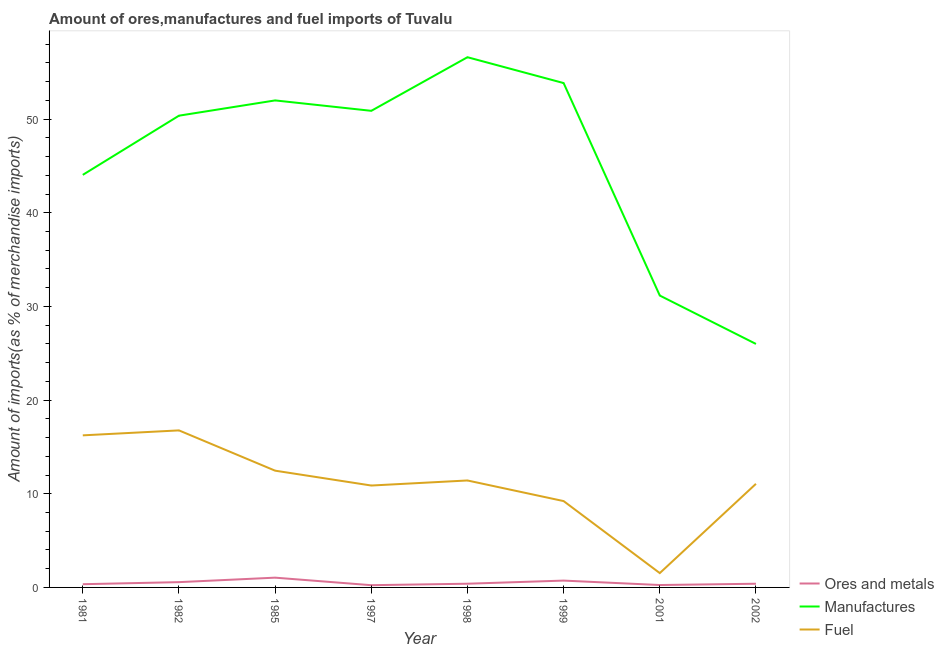How many different coloured lines are there?
Provide a short and direct response. 3. Does the line corresponding to percentage of manufactures imports intersect with the line corresponding to percentage of fuel imports?
Provide a succinct answer. No. Is the number of lines equal to the number of legend labels?
Keep it short and to the point. Yes. What is the percentage of ores and metals imports in 1999?
Your response must be concise. 0.73. Across all years, what is the maximum percentage of fuel imports?
Offer a very short reply. 16.77. Across all years, what is the minimum percentage of fuel imports?
Keep it short and to the point. 1.53. In which year was the percentage of fuel imports maximum?
Ensure brevity in your answer.  1982. In which year was the percentage of fuel imports minimum?
Keep it short and to the point. 2001. What is the total percentage of manufactures imports in the graph?
Keep it short and to the point. 364.89. What is the difference between the percentage of ores and metals imports in 1997 and that in 1998?
Ensure brevity in your answer.  -0.16. What is the difference between the percentage of manufactures imports in 1997 and the percentage of fuel imports in 1982?
Make the answer very short. 34.12. What is the average percentage of fuel imports per year?
Keep it short and to the point. 11.2. In the year 1999, what is the difference between the percentage of manufactures imports and percentage of ores and metals imports?
Ensure brevity in your answer.  53.12. In how many years, is the percentage of fuel imports greater than 2 %?
Ensure brevity in your answer.  7. What is the ratio of the percentage of manufactures imports in 1998 to that in 2002?
Make the answer very short. 2.18. Is the percentage of ores and metals imports in 1981 less than that in 2002?
Give a very brief answer. Yes. Is the difference between the percentage of fuel imports in 1981 and 1982 greater than the difference between the percentage of manufactures imports in 1981 and 1982?
Your answer should be very brief. Yes. What is the difference between the highest and the second highest percentage of ores and metals imports?
Offer a terse response. 0.31. What is the difference between the highest and the lowest percentage of manufactures imports?
Offer a terse response. 30.61. In how many years, is the percentage of fuel imports greater than the average percentage of fuel imports taken over all years?
Make the answer very short. 4. Is it the case that in every year, the sum of the percentage of ores and metals imports and percentage of manufactures imports is greater than the percentage of fuel imports?
Keep it short and to the point. Yes. How many lines are there?
Provide a short and direct response. 3. How many years are there in the graph?
Offer a very short reply. 8. What is the difference between two consecutive major ticks on the Y-axis?
Your answer should be very brief. 10. Are the values on the major ticks of Y-axis written in scientific E-notation?
Your answer should be very brief. No. Does the graph contain grids?
Make the answer very short. No. How many legend labels are there?
Your response must be concise. 3. What is the title of the graph?
Offer a terse response. Amount of ores,manufactures and fuel imports of Tuvalu. What is the label or title of the Y-axis?
Your answer should be compact. Amount of imports(as % of merchandise imports). What is the Amount of imports(as % of merchandise imports) of Ores and metals in 1981?
Offer a terse response. 0.34. What is the Amount of imports(as % of merchandise imports) of Manufactures in 1981?
Your answer should be very brief. 44.04. What is the Amount of imports(as % of merchandise imports) of Fuel in 1981?
Your response must be concise. 16.24. What is the Amount of imports(as % of merchandise imports) in Ores and metals in 1982?
Provide a short and direct response. 0.56. What is the Amount of imports(as % of merchandise imports) of Manufactures in 1982?
Keep it short and to the point. 50.36. What is the Amount of imports(as % of merchandise imports) in Fuel in 1982?
Ensure brevity in your answer.  16.77. What is the Amount of imports(as % of merchandise imports) of Ores and metals in 1985?
Make the answer very short. 1.04. What is the Amount of imports(as % of merchandise imports) of Manufactures in 1985?
Provide a succinct answer. 51.99. What is the Amount of imports(as % of merchandise imports) in Fuel in 1985?
Ensure brevity in your answer.  12.46. What is the Amount of imports(as % of merchandise imports) of Ores and metals in 1997?
Make the answer very short. 0.24. What is the Amount of imports(as % of merchandise imports) in Manufactures in 1997?
Provide a short and direct response. 50.88. What is the Amount of imports(as % of merchandise imports) in Fuel in 1997?
Give a very brief answer. 10.88. What is the Amount of imports(as % of merchandise imports) in Ores and metals in 1998?
Your answer should be very brief. 0.4. What is the Amount of imports(as % of merchandise imports) of Manufactures in 1998?
Offer a terse response. 56.6. What is the Amount of imports(as % of merchandise imports) in Fuel in 1998?
Provide a succinct answer. 11.42. What is the Amount of imports(as % of merchandise imports) of Ores and metals in 1999?
Keep it short and to the point. 0.73. What is the Amount of imports(as % of merchandise imports) of Manufactures in 1999?
Your answer should be very brief. 53.85. What is the Amount of imports(as % of merchandise imports) of Fuel in 1999?
Provide a succinct answer. 9.22. What is the Amount of imports(as % of merchandise imports) in Ores and metals in 2001?
Offer a terse response. 0.26. What is the Amount of imports(as % of merchandise imports) of Manufactures in 2001?
Provide a succinct answer. 31.16. What is the Amount of imports(as % of merchandise imports) of Fuel in 2001?
Offer a terse response. 1.53. What is the Amount of imports(as % of merchandise imports) of Ores and metals in 2002?
Make the answer very short. 0.39. What is the Amount of imports(as % of merchandise imports) of Manufactures in 2002?
Ensure brevity in your answer.  25.99. What is the Amount of imports(as % of merchandise imports) in Fuel in 2002?
Your answer should be compact. 11.06. Across all years, what is the maximum Amount of imports(as % of merchandise imports) in Ores and metals?
Make the answer very short. 1.04. Across all years, what is the maximum Amount of imports(as % of merchandise imports) in Manufactures?
Provide a short and direct response. 56.6. Across all years, what is the maximum Amount of imports(as % of merchandise imports) of Fuel?
Your response must be concise. 16.77. Across all years, what is the minimum Amount of imports(as % of merchandise imports) of Ores and metals?
Provide a short and direct response. 0.24. Across all years, what is the minimum Amount of imports(as % of merchandise imports) of Manufactures?
Ensure brevity in your answer.  25.99. Across all years, what is the minimum Amount of imports(as % of merchandise imports) of Fuel?
Offer a very short reply. 1.53. What is the total Amount of imports(as % of merchandise imports) in Ores and metals in the graph?
Give a very brief answer. 3.97. What is the total Amount of imports(as % of merchandise imports) in Manufactures in the graph?
Make the answer very short. 364.89. What is the total Amount of imports(as % of merchandise imports) in Fuel in the graph?
Offer a very short reply. 89.57. What is the difference between the Amount of imports(as % of merchandise imports) of Ores and metals in 1981 and that in 1982?
Give a very brief answer. -0.22. What is the difference between the Amount of imports(as % of merchandise imports) in Manufactures in 1981 and that in 1982?
Offer a very short reply. -6.32. What is the difference between the Amount of imports(as % of merchandise imports) of Fuel in 1981 and that in 1982?
Provide a short and direct response. -0.53. What is the difference between the Amount of imports(as % of merchandise imports) of Ores and metals in 1981 and that in 1985?
Your answer should be very brief. -0.7. What is the difference between the Amount of imports(as % of merchandise imports) of Manufactures in 1981 and that in 1985?
Make the answer very short. -7.95. What is the difference between the Amount of imports(as % of merchandise imports) of Fuel in 1981 and that in 1985?
Provide a succinct answer. 3.77. What is the difference between the Amount of imports(as % of merchandise imports) in Ores and metals in 1981 and that in 1997?
Make the answer very short. 0.11. What is the difference between the Amount of imports(as % of merchandise imports) in Manufactures in 1981 and that in 1997?
Ensure brevity in your answer.  -6.84. What is the difference between the Amount of imports(as % of merchandise imports) of Fuel in 1981 and that in 1997?
Offer a very short reply. 5.36. What is the difference between the Amount of imports(as % of merchandise imports) in Ores and metals in 1981 and that in 1998?
Keep it short and to the point. -0.05. What is the difference between the Amount of imports(as % of merchandise imports) of Manufactures in 1981 and that in 1998?
Offer a very short reply. -12.56. What is the difference between the Amount of imports(as % of merchandise imports) in Fuel in 1981 and that in 1998?
Your response must be concise. 4.82. What is the difference between the Amount of imports(as % of merchandise imports) in Ores and metals in 1981 and that in 1999?
Provide a succinct answer. -0.39. What is the difference between the Amount of imports(as % of merchandise imports) in Manufactures in 1981 and that in 1999?
Provide a succinct answer. -9.8. What is the difference between the Amount of imports(as % of merchandise imports) of Fuel in 1981 and that in 1999?
Your answer should be compact. 7.02. What is the difference between the Amount of imports(as % of merchandise imports) of Ores and metals in 1981 and that in 2001?
Your response must be concise. 0.09. What is the difference between the Amount of imports(as % of merchandise imports) in Manufactures in 1981 and that in 2001?
Provide a succinct answer. 12.88. What is the difference between the Amount of imports(as % of merchandise imports) in Fuel in 1981 and that in 2001?
Provide a short and direct response. 14.71. What is the difference between the Amount of imports(as % of merchandise imports) in Ores and metals in 1981 and that in 2002?
Your response must be concise. -0.05. What is the difference between the Amount of imports(as % of merchandise imports) of Manufactures in 1981 and that in 2002?
Offer a very short reply. 18.05. What is the difference between the Amount of imports(as % of merchandise imports) in Fuel in 1981 and that in 2002?
Ensure brevity in your answer.  5.17. What is the difference between the Amount of imports(as % of merchandise imports) of Ores and metals in 1982 and that in 1985?
Offer a terse response. -0.48. What is the difference between the Amount of imports(as % of merchandise imports) of Manufactures in 1982 and that in 1985?
Provide a short and direct response. -1.63. What is the difference between the Amount of imports(as % of merchandise imports) of Fuel in 1982 and that in 1985?
Keep it short and to the point. 4.3. What is the difference between the Amount of imports(as % of merchandise imports) in Ores and metals in 1982 and that in 1997?
Keep it short and to the point. 0.33. What is the difference between the Amount of imports(as % of merchandise imports) of Manufactures in 1982 and that in 1997?
Your response must be concise. -0.52. What is the difference between the Amount of imports(as % of merchandise imports) in Fuel in 1982 and that in 1997?
Keep it short and to the point. 5.89. What is the difference between the Amount of imports(as % of merchandise imports) in Ores and metals in 1982 and that in 1998?
Your response must be concise. 0.17. What is the difference between the Amount of imports(as % of merchandise imports) in Manufactures in 1982 and that in 1998?
Make the answer very short. -6.24. What is the difference between the Amount of imports(as % of merchandise imports) of Fuel in 1982 and that in 1998?
Ensure brevity in your answer.  5.35. What is the difference between the Amount of imports(as % of merchandise imports) of Ores and metals in 1982 and that in 1999?
Provide a short and direct response. -0.17. What is the difference between the Amount of imports(as % of merchandise imports) in Manufactures in 1982 and that in 1999?
Offer a terse response. -3.48. What is the difference between the Amount of imports(as % of merchandise imports) in Fuel in 1982 and that in 1999?
Give a very brief answer. 7.55. What is the difference between the Amount of imports(as % of merchandise imports) in Ores and metals in 1982 and that in 2001?
Offer a very short reply. 0.31. What is the difference between the Amount of imports(as % of merchandise imports) in Manufactures in 1982 and that in 2001?
Provide a succinct answer. 19.2. What is the difference between the Amount of imports(as % of merchandise imports) in Fuel in 1982 and that in 2001?
Give a very brief answer. 15.24. What is the difference between the Amount of imports(as % of merchandise imports) of Ores and metals in 1982 and that in 2002?
Your answer should be compact. 0.17. What is the difference between the Amount of imports(as % of merchandise imports) of Manufactures in 1982 and that in 2002?
Keep it short and to the point. 24.37. What is the difference between the Amount of imports(as % of merchandise imports) of Fuel in 1982 and that in 2002?
Give a very brief answer. 5.71. What is the difference between the Amount of imports(as % of merchandise imports) of Ores and metals in 1985 and that in 1997?
Give a very brief answer. 0.8. What is the difference between the Amount of imports(as % of merchandise imports) in Manufactures in 1985 and that in 1997?
Your answer should be very brief. 1.11. What is the difference between the Amount of imports(as % of merchandise imports) in Fuel in 1985 and that in 1997?
Offer a very short reply. 1.59. What is the difference between the Amount of imports(as % of merchandise imports) in Ores and metals in 1985 and that in 1998?
Make the answer very short. 0.65. What is the difference between the Amount of imports(as % of merchandise imports) of Manufactures in 1985 and that in 1998?
Offer a very short reply. -4.61. What is the difference between the Amount of imports(as % of merchandise imports) in Fuel in 1985 and that in 1998?
Your answer should be very brief. 1.05. What is the difference between the Amount of imports(as % of merchandise imports) in Ores and metals in 1985 and that in 1999?
Keep it short and to the point. 0.31. What is the difference between the Amount of imports(as % of merchandise imports) in Manufactures in 1985 and that in 1999?
Keep it short and to the point. -1.85. What is the difference between the Amount of imports(as % of merchandise imports) of Fuel in 1985 and that in 1999?
Provide a succinct answer. 3.25. What is the difference between the Amount of imports(as % of merchandise imports) in Ores and metals in 1985 and that in 2001?
Offer a terse response. 0.79. What is the difference between the Amount of imports(as % of merchandise imports) in Manufactures in 1985 and that in 2001?
Make the answer very short. 20.83. What is the difference between the Amount of imports(as % of merchandise imports) in Fuel in 1985 and that in 2001?
Provide a short and direct response. 10.94. What is the difference between the Amount of imports(as % of merchandise imports) in Ores and metals in 1985 and that in 2002?
Your response must be concise. 0.65. What is the difference between the Amount of imports(as % of merchandise imports) of Manufactures in 1985 and that in 2002?
Provide a succinct answer. 26. What is the difference between the Amount of imports(as % of merchandise imports) in Fuel in 1985 and that in 2002?
Keep it short and to the point. 1.4. What is the difference between the Amount of imports(as % of merchandise imports) in Ores and metals in 1997 and that in 1998?
Give a very brief answer. -0.16. What is the difference between the Amount of imports(as % of merchandise imports) in Manufactures in 1997 and that in 1998?
Ensure brevity in your answer.  -5.72. What is the difference between the Amount of imports(as % of merchandise imports) in Fuel in 1997 and that in 1998?
Offer a very short reply. -0.54. What is the difference between the Amount of imports(as % of merchandise imports) in Ores and metals in 1997 and that in 1999?
Your answer should be very brief. -0.49. What is the difference between the Amount of imports(as % of merchandise imports) of Manufactures in 1997 and that in 1999?
Give a very brief answer. -2.96. What is the difference between the Amount of imports(as % of merchandise imports) of Fuel in 1997 and that in 1999?
Provide a short and direct response. 1.66. What is the difference between the Amount of imports(as % of merchandise imports) of Ores and metals in 1997 and that in 2001?
Keep it short and to the point. -0.02. What is the difference between the Amount of imports(as % of merchandise imports) of Manufactures in 1997 and that in 2001?
Your answer should be very brief. 19.72. What is the difference between the Amount of imports(as % of merchandise imports) in Fuel in 1997 and that in 2001?
Your answer should be compact. 9.35. What is the difference between the Amount of imports(as % of merchandise imports) of Ores and metals in 1997 and that in 2002?
Make the answer very short. -0.15. What is the difference between the Amount of imports(as % of merchandise imports) of Manufactures in 1997 and that in 2002?
Give a very brief answer. 24.89. What is the difference between the Amount of imports(as % of merchandise imports) in Fuel in 1997 and that in 2002?
Provide a short and direct response. -0.18. What is the difference between the Amount of imports(as % of merchandise imports) of Ores and metals in 1998 and that in 1999?
Provide a short and direct response. -0.33. What is the difference between the Amount of imports(as % of merchandise imports) in Manufactures in 1998 and that in 1999?
Provide a succinct answer. 2.76. What is the difference between the Amount of imports(as % of merchandise imports) in Fuel in 1998 and that in 1999?
Make the answer very short. 2.2. What is the difference between the Amount of imports(as % of merchandise imports) of Ores and metals in 1998 and that in 2001?
Your answer should be very brief. 0.14. What is the difference between the Amount of imports(as % of merchandise imports) in Manufactures in 1998 and that in 2001?
Offer a very short reply. 25.44. What is the difference between the Amount of imports(as % of merchandise imports) in Fuel in 1998 and that in 2001?
Offer a very short reply. 9.89. What is the difference between the Amount of imports(as % of merchandise imports) in Ores and metals in 1998 and that in 2002?
Your answer should be compact. 0. What is the difference between the Amount of imports(as % of merchandise imports) of Manufactures in 1998 and that in 2002?
Provide a succinct answer. 30.61. What is the difference between the Amount of imports(as % of merchandise imports) in Fuel in 1998 and that in 2002?
Provide a succinct answer. 0.36. What is the difference between the Amount of imports(as % of merchandise imports) in Ores and metals in 1999 and that in 2001?
Make the answer very short. 0.47. What is the difference between the Amount of imports(as % of merchandise imports) in Manufactures in 1999 and that in 2001?
Ensure brevity in your answer.  22.68. What is the difference between the Amount of imports(as % of merchandise imports) of Fuel in 1999 and that in 2001?
Keep it short and to the point. 7.69. What is the difference between the Amount of imports(as % of merchandise imports) in Ores and metals in 1999 and that in 2002?
Ensure brevity in your answer.  0.34. What is the difference between the Amount of imports(as % of merchandise imports) in Manufactures in 1999 and that in 2002?
Offer a terse response. 27.85. What is the difference between the Amount of imports(as % of merchandise imports) in Fuel in 1999 and that in 2002?
Ensure brevity in your answer.  -1.84. What is the difference between the Amount of imports(as % of merchandise imports) of Ores and metals in 2001 and that in 2002?
Your answer should be compact. -0.14. What is the difference between the Amount of imports(as % of merchandise imports) of Manufactures in 2001 and that in 2002?
Your answer should be very brief. 5.17. What is the difference between the Amount of imports(as % of merchandise imports) of Fuel in 2001 and that in 2002?
Your response must be concise. -9.53. What is the difference between the Amount of imports(as % of merchandise imports) in Ores and metals in 1981 and the Amount of imports(as % of merchandise imports) in Manufactures in 1982?
Provide a short and direct response. -50.02. What is the difference between the Amount of imports(as % of merchandise imports) of Ores and metals in 1981 and the Amount of imports(as % of merchandise imports) of Fuel in 1982?
Your answer should be compact. -16.42. What is the difference between the Amount of imports(as % of merchandise imports) in Manufactures in 1981 and the Amount of imports(as % of merchandise imports) in Fuel in 1982?
Your answer should be compact. 27.28. What is the difference between the Amount of imports(as % of merchandise imports) of Ores and metals in 1981 and the Amount of imports(as % of merchandise imports) of Manufactures in 1985?
Keep it short and to the point. -51.65. What is the difference between the Amount of imports(as % of merchandise imports) in Ores and metals in 1981 and the Amount of imports(as % of merchandise imports) in Fuel in 1985?
Ensure brevity in your answer.  -12.12. What is the difference between the Amount of imports(as % of merchandise imports) in Manufactures in 1981 and the Amount of imports(as % of merchandise imports) in Fuel in 1985?
Your answer should be very brief. 31.58. What is the difference between the Amount of imports(as % of merchandise imports) in Ores and metals in 1981 and the Amount of imports(as % of merchandise imports) in Manufactures in 1997?
Your response must be concise. -50.54. What is the difference between the Amount of imports(as % of merchandise imports) of Ores and metals in 1981 and the Amount of imports(as % of merchandise imports) of Fuel in 1997?
Provide a short and direct response. -10.53. What is the difference between the Amount of imports(as % of merchandise imports) in Manufactures in 1981 and the Amount of imports(as % of merchandise imports) in Fuel in 1997?
Your response must be concise. 33.17. What is the difference between the Amount of imports(as % of merchandise imports) in Ores and metals in 1981 and the Amount of imports(as % of merchandise imports) in Manufactures in 1998?
Offer a very short reply. -56.26. What is the difference between the Amount of imports(as % of merchandise imports) in Ores and metals in 1981 and the Amount of imports(as % of merchandise imports) in Fuel in 1998?
Offer a very short reply. -11.07. What is the difference between the Amount of imports(as % of merchandise imports) of Manufactures in 1981 and the Amount of imports(as % of merchandise imports) of Fuel in 1998?
Make the answer very short. 32.63. What is the difference between the Amount of imports(as % of merchandise imports) in Ores and metals in 1981 and the Amount of imports(as % of merchandise imports) in Manufactures in 1999?
Provide a succinct answer. -53.5. What is the difference between the Amount of imports(as % of merchandise imports) of Ores and metals in 1981 and the Amount of imports(as % of merchandise imports) of Fuel in 1999?
Give a very brief answer. -8.87. What is the difference between the Amount of imports(as % of merchandise imports) of Manufactures in 1981 and the Amount of imports(as % of merchandise imports) of Fuel in 1999?
Your answer should be very brief. 34.83. What is the difference between the Amount of imports(as % of merchandise imports) in Ores and metals in 1981 and the Amount of imports(as % of merchandise imports) in Manufactures in 2001?
Give a very brief answer. -30.82. What is the difference between the Amount of imports(as % of merchandise imports) of Ores and metals in 1981 and the Amount of imports(as % of merchandise imports) of Fuel in 2001?
Your response must be concise. -1.19. What is the difference between the Amount of imports(as % of merchandise imports) of Manufactures in 1981 and the Amount of imports(as % of merchandise imports) of Fuel in 2001?
Offer a terse response. 42.51. What is the difference between the Amount of imports(as % of merchandise imports) in Ores and metals in 1981 and the Amount of imports(as % of merchandise imports) in Manufactures in 2002?
Your answer should be very brief. -25.65. What is the difference between the Amount of imports(as % of merchandise imports) of Ores and metals in 1981 and the Amount of imports(as % of merchandise imports) of Fuel in 2002?
Provide a short and direct response. -10.72. What is the difference between the Amount of imports(as % of merchandise imports) of Manufactures in 1981 and the Amount of imports(as % of merchandise imports) of Fuel in 2002?
Your response must be concise. 32.98. What is the difference between the Amount of imports(as % of merchandise imports) of Ores and metals in 1982 and the Amount of imports(as % of merchandise imports) of Manufactures in 1985?
Provide a short and direct response. -51.43. What is the difference between the Amount of imports(as % of merchandise imports) of Ores and metals in 1982 and the Amount of imports(as % of merchandise imports) of Fuel in 1985?
Provide a succinct answer. -11.9. What is the difference between the Amount of imports(as % of merchandise imports) of Manufactures in 1982 and the Amount of imports(as % of merchandise imports) of Fuel in 1985?
Give a very brief answer. 37.9. What is the difference between the Amount of imports(as % of merchandise imports) in Ores and metals in 1982 and the Amount of imports(as % of merchandise imports) in Manufactures in 1997?
Provide a short and direct response. -50.32. What is the difference between the Amount of imports(as % of merchandise imports) of Ores and metals in 1982 and the Amount of imports(as % of merchandise imports) of Fuel in 1997?
Offer a very short reply. -10.31. What is the difference between the Amount of imports(as % of merchandise imports) in Manufactures in 1982 and the Amount of imports(as % of merchandise imports) in Fuel in 1997?
Make the answer very short. 39.48. What is the difference between the Amount of imports(as % of merchandise imports) of Ores and metals in 1982 and the Amount of imports(as % of merchandise imports) of Manufactures in 1998?
Provide a succinct answer. -56.04. What is the difference between the Amount of imports(as % of merchandise imports) of Ores and metals in 1982 and the Amount of imports(as % of merchandise imports) of Fuel in 1998?
Make the answer very short. -10.85. What is the difference between the Amount of imports(as % of merchandise imports) in Manufactures in 1982 and the Amount of imports(as % of merchandise imports) in Fuel in 1998?
Offer a terse response. 38.94. What is the difference between the Amount of imports(as % of merchandise imports) of Ores and metals in 1982 and the Amount of imports(as % of merchandise imports) of Manufactures in 1999?
Offer a very short reply. -53.28. What is the difference between the Amount of imports(as % of merchandise imports) of Ores and metals in 1982 and the Amount of imports(as % of merchandise imports) of Fuel in 1999?
Offer a very short reply. -8.65. What is the difference between the Amount of imports(as % of merchandise imports) of Manufactures in 1982 and the Amount of imports(as % of merchandise imports) of Fuel in 1999?
Keep it short and to the point. 41.14. What is the difference between the Amount of imports(as % of merchandise imports) in Ores and metals in 1982 and the Amount of imports(as % of merchandise imports) in Manufactures in 2001?
Keep it short and to the point. -30.6. What is the difference between the Amount of imports(as % of merchandise imports) of Ores and metals in 1982 and the Amount of imports(as % of merchandise imports) of Fuel in 2001?
Your answer should be compact. -0.96. What is the difference between the Amount of imports(as % of merchandise imports) in Manufactures in 1982 and the Amount of imports(as % of merchandise imports) in Fuel in 2001?
Offer a terse response. 48.83. What is the difference between the Amount of imports(as % of merchandise imports) in Ores and metals in 1982 and the Amount of imports(as % of merchandise imports) in Manufactures in 2002?
Offer a terse response. -25.43. What is the difference between the Amount of imports(as % of merchandise imports) of Ores and metals in 1982 and the Amount of imports(as % of merchandise imports) of Fuel in 2002?
Offer a very short reply. -10.5. What is the difference between the Amount of imports(as % of merchandise imports) of Manufactures in 1982 and the Amount of imports(as % of merchandise imports) of Fuel in 2002?
Your answer should be very brief. 39.3. What is the difference between the Amount of imports(as % of merchandise imports) in Ores and metals in 1985 and the Amount of imports(as % of merchandise imports) in Manufactures in 1997?
Give a very brief answer. -49.84. What is the difference between the Amount of imports(as % of merchandise imports) of Ores and metals in 1985 and the Amount of imports(as % of merchandise imports) of Fuel in 1997?
Offer a terse response. -9.84. What is the difference between the Amount of imports(as % of merchandise imports) in Manufactures in 1985 and the Amount of imports(as % of merchandise imports) in Fuel in 1997?
Offer a terse response. 41.11. What is the difference between the Amount of imports(as % of merchandise imports) of Ores and metals in 1985 and the Amount of imports(as % of merchandise imports) of Manufactures in 1998?
Offer a very short reply. -55.56. What is the difference between the Amount of imports(as % of merchandise imports) in Ores and metals in 1985 and the Amount of imports(as % of merchandise imports) in Fuel in 1998?
Provide a short and direct response. -10.38. What is the difference between the Amount of imports(as % of merchandise imports) in Manufactures in 1985 and the Amount of imports(as % of merchandise imports) in Fuel in 1998?
Make the answer very short. 40.57. What is the difference between the Amount of imports(as % of merchandise imports) of Ores and metals in 1985 and the Amount of imports(as % of merchandise imports) of Manufactures in 1999?
Provide a succinct answer. -52.8. What is the difference between the Amount of imports(as % of merchandise imports) in Ores and metals in 1985 and the Amount of imports(as % of merchandise imports) in Fuel in 1999?
Provide a short and direct response. -8.18. What is the difference between the Amount of imports(as % of merchandise imports) in Manufactures in 1985 and the Amount of imports(as % of merchandise imports) in Fuel in 1999?
Your answer should be very brief. 42.77. What is the difference between the Amount of imports(as % of merchandise imports) in Ores and metals in 1985 and the Amount of imports(as % of merchandise imports) in Manufactures in 2001?
Keep it short and to the point. -30.12. What is the difference between the Amount of imports(as % of merchandise imports) of Ores and metals in 1985 and the Amount of imports(as % of merchandise imports) of Fuel in 2001?
Your response must be concise. -0.49. What is the difference between the Amount of imports(as % of merchandise imports) in Manufactures in 1985 and the Amount of imports(as % of merchandise imports) in Fuel in 2001?
Offer a terse response. 50.46. What is the difference between the Amount of imports(as % of merchandise imports) in Ores and metals in 1985 and the Amount of imports(as % of merchandise imports) in Manufactures in 2002?
Provide a short and direct response. -24.95. What is the difference between the Amount of imports(as % of merchandise imports) in Ores and metals in 1985 and the Amount of imports(as % of merchandise imports) in Fuel in 2002?
Offer a terse response. -10.02. What is the difference between the Amount of imports(as % of merchandise imports) in Manufactures in 1985 and the Amount of imports(as % of merchandise imports) in Fuel in 2002?
Your response must be concise. 40.93. What is the difference between the Amount of imports(as % of merchandise imports) in Ores and metals in 1997 and the Amount of imports(as % of merchandise imports) in Manufactures in 1998?
Offer a terse response. -56.37. What is the difference between the Amount of imports(as % of merchandise imports) of Ores and metals in 1997 and the Amount of imports(as % of merchandise imports) of Fuel in 1998?
Keep it short and to the point. -11.18. What is the difference between the Amount of imports(as % of merchandise imports) of Manufactures in 1997 and the Amount of imports(as % of merchandise imports) of Fuel in 1998?
Your answer should be very brief. 39.46. What is the difference between the Amount of imports(as % of merchandise imports) in Ores and metals in 1997 and the Amount of imports(as % of merchandise imports) in Manufactures in 1999?
Ensure brevity in your answer.  -53.61. What is the difference between the Amount of imports(as % of merchandise imports) of Ores and metals in 1997 and the Amount of imports(as % of merchandise imports) of Fuel in 1999?
Keep it short and to the point. -8.98. What is the difference between the Amount of imports(as % of merchandise imports) of Manufactures in 1997 and the Amount of imports(as % of merchandise imports) of Fuel in 1999?
Make the answer very short. 41.66. What is the difference between the Amount of imports(as % of merchandise imports) in Ores and metals in 1997 and the Amount of imports(as % of merchandise imports) in Manufactures in 2001?
Make the answer very short. -30.92. What is the difference between the Amount of imports(as % of merchandise imports) in Ores and metals in 1997 and the Amount of imports(as % of merchandise imports) in Fuel in 2001?
Make the answer very short. -1.29. What is the difference between the Amount of imports(as % of merchandise imports) of Manufactures in 1997 and the Amount of imports(as % of merchandise imports) of Fuel in 2001?
Provide a succinct answer. 49.35. What is the difference between the Amount of imports(as % of merchandise imports) in Ores and metals in 1997 and the Amount of imports(as % of merchandise imports) in Manufactures in 2002?
Keep it short and to the point. -25.76. What is the difference between the Amount of imports(as % of merchandise imports) of Ores and metals in 1997 and the Amount of imports(as % of merchandise imports) of Fuel in 2002?
Offer a terse response. -10.82. What is the difference between the Amount of imports(as % of merchandise imports) of Manufactures in 1997 and the Amount of imports(as % of merchandise imports) of Fuel in 2002?
Make the answer very short. 39.82. What is the difference between the Amount of imports(as % of merchandise imports) in Ores and metals in 1998 and the Amount of imports(as % of merchandise imports) in Manufactures in 1999?
Provide a succinct answer. -53.45. What is the difference between the Amount of imports(as % of merchandise imports) of Ores and metals in 1998 and the Amount of imports(as % of merchandise imports) of Fuel in 1999?
Your answer should be compact. -8.82. What is the difference between the Amount of imports(as % of merchandise imports) of Manufactures in 1998 and the Amount of imports(as % of merchandise imports) of Fuel in 1999?
Your answer should be very brief. 47.39. What is the difference between the Amount of imports(as % of merchandise imports) in Ores and metals in 1998 and the Amount of imports(as % of merchandise imports) in Manufactures in 2001?
Provide a succinct answer. -30.77. What is the difference between the Amount of imports(as % of merchandise imports) in Ores and metals in 1998 and the Amount of imports(as % of merchandise imports) in Fuel in 2001?
Your response must be concise. -1.13. What is the difference between the Amount of imports(as % of merchandise imports) in Manufactures in 1998 and the Amount of imports(as % of merchandise imports) in Fuel in 2001?
Keep it short and to the point. 55.07. What is the difference between the Amount of imports(as % of merchandise imports) of Ores and metals in 1998 and the Amount of imports(as % of merchandise imports) of Manufactures in 2002?
Offer a very short reply. -25.6. What is the difference between the Amount of imports(as % of merchandise imports) in Ores and metals in 1998 and the Amount of imports(as % of merchandise imports) in Fuel in 2002?
Provide a succinct answer. -10.66. What is the difference between the Amount of imports(as % of merchandise imports) in Manufactures in 1998 and the Amount of imports(as % of merchandise imports) in Fuel in 2002?
Give a very brief answer. 45.54. What is the difference between the Amount of imports(as % of merchandise imports) of Ores and metals in 1999 and the Amount of imports(as % of merchandise imports) of Manufactures in 2001?
Keep it short and to the point. -30.43. What is the difference between the Amount of imports(as % of merchandise imports) of Ores and metals in 1999 and the Amount of imports(as % of merchandise imports) of Fuel in 2001?
Your answer should be compact. -0.8. What is the difference between the Amount of imports(as % of merchandise imports) in Manufactures in 1999 and the Amount of imports(as % of merchandise imports) in Fuel in 2001?
Provide a short and direct response. 52.32. What is the difference between the Amount of imports(as % of merchandise imports) of Ores and metals in 1999 and the Amount of imports(as % of merchandise imports) of Manufactures in 2002?
Your answer should be very brief. -25.26. What is the difference between the Amount of imports(as % of merchandise imports) in Ores and metals in 1999 and the Amount of imports(as % of merchandise imports) in Fuel in 2002?
Offer a very short reply. -10.33. What is the difference between the Amount of imports(as % of merchandise imports) in Manufactures in 1999 and the Amount of imports(as % of merchandise imports) in Fuel in 2002?
Ensure brevity in your answer.  42.78. What is the difference between the Amount of imports(as % of merchandise imports) in Ores and metals in 2001 and the Amount of imports(as % of merchandise imports) in Manufactures in 2002?
Provide a succinct answer. -25.74. What is the difference between the Amount of imports(as % of merchandise imports) of Ores and metals in 2001 and the Amount of imports(as % of merchandise imports) of Fuel in 2002?
Ensure brevity in your answer.  -10.8. What is the difference between the Amount of imports(as % of merchandise imports) in Manufactures in 2001 and the Amount of imports(as % of merchandise imports) in Fuel in 2002?
Provide a short and direct response. 20.1. What is the average Amount of imports(as % of merchandise imports) of Ores and metals per year?
Keep it short and to the point. 0.5. What is the average Amount of imports(as % of merchandise imports) of Manufactures per year?
Make the answer very short. 45.61. What is the average Amount of imports(as % of merchandise imports) in Fuel per year?
Provide a short and direct response. 11.2. In the year 1981, what is the difference between the Amount of imports(as % of merchandise imports) of Ores and metals and Amount of imports(as % of merchandise imports) of Manufactures?
Ensure brevity in your answer.  -43.7. In the year 1981, what is the difference between the Amount of imports(as % of merchandise imports) of Ores and metals and Amount of imports(as % of merchandise imports) of Fuel?
Offer a terse response. -15.89. In the year 1981, what is the difference between the Amount of imports(as % of merchandise imports) in Manufactures and Amount of imports(as % of merchandise imports) in Fuel?
Your response must be concise. 27.81. In the year 1982, what is the difference between the Amount of imports(as % of merchandise imports) of Ores and metals and Amount of imports(as % of merchandise imports) of Manufactures?
Keep it short and to the point. -49.8. In the year 1982, what is the difference between the Amount of imports(as % of merchandise imports) of Ores and metals and Amount of imports(as % of merchandise imports) of Fuel?
Offer a very short reply. -16.2. In the year 1982, what is the difference between the Amount of imports(as % of merchandise imports) in Manufactures and Amount of imports(as % of merchandise imports) in Fuel?
Offer a terse response. 33.6. In the year 1985, what is the difference between the Amount of imports(as % of merchandise imports) of Ores and metals and Amount of imports(as % of merchandise imports) of Manufactures?
Offer a very short reply. -50.95. In the year 1985, what is the difference between the Amount of imports(as % of merchandise imports) of Ores and metals and Amount of imports(as % of merchandise imports) of Fuel?
Offer a very short reply. -11.42. In the year 1985, what is the difference between the Amount of imports(as % of merchandise imports) of Manufactures and Amount of imports(as % of merchandise imports) of Fuel?
Offer a terse response. 39.53. In the year 1997, what is the difference between the Amount of imports(as % of merchandise imports) in Ores and metals and Amount of imports(as % of merchandise imports) in Manufactures?
Your answer should be very brief. -50.64. In the year 1997, what is the difference between the Amount of imports(as % of merchandise imports) of Ores and metals and Amount of imports(as % of merchandise imports) of Fuel?
Ensure brevity in your answer.  -10.64. In the year 1997, what is the difference between the Amount of imports(as % of merchandise imports) in Manufactures and Amount of imports(as % of merchandise imports) in Fuel?
Your answer should be compact. 40. In the year 1998, what is the difference between the Amount of imports(as % of merchandise imports) of Ores and metals and Amount of imports(as % of merchandise imports) of Manufactures?
Give a very brief answer. -56.21. In the year 1998, what is the difference between the Amount of imports(as % of merchandise imports) in Ores and metals and Amount of imports(as % of merchandise imports) in Fuel?
Provide a short and direct response. -11.02. In the year 1998, what is the difference between the Amount of imports(as % of merchandise imports) of Manufactures and Amount of imports(as % of merchandise imports) of Fuel?
Ensure brevity in your answer.  45.19. In the year 1999, what is the difference between the Amount of imports(as % of merchandise imports) in Ores and metals and Amount of imports(as % of merchandise imports) in Manufactures?
Offer a terse response. -53.12. In the year 1999, what is the difference between the Amount of imports(as % of merchandise imports) in Ores and metals and Amount of imports(as % of merchandise imports) in Fuel?
Keep it short and to the point. -8.49. In the year 1999, what is the difference between the Amount of imports(as % of merchandise imports) of Manufactures and Amount of imports(as % of merchandise imports) of Fuel?
Your answer should be very brief. 44.63. In the year 2001, what is the difference between the Amount of imports(as % of merchandise imports) of Ores and metals and Amount of imports(as % of merchandise imports) of Manufactures?
Your response must be concise. -30.9. In the year 2001, what is the difference between the Amount of imports(as % of merchandise imports) in Ores and metals and Amount of imports(as % of merchandise imports) in Fuel?
Provide a short and direct response. -1.27. In the year 2001, what is the difference between the Amount of imports(as % of merchandise imports) of Manufactures and Amount of imports(as % of merchandise imports) of Fuel?
Offer a very short reply. 29.63. In the year 2002, what is the difference between the Amount of imports(as % of merchandise imports) of Ores and metals and Amount of imports(as % of merchandise imports) of Manufactures?
Ensure brevity in your answer.  -25.6. In the year 2002, what is the difference between the Amount of imports(as % of merchandise imports) in Ores and metals and Amount of imports(as % of merchandise imports) in Fuel?
Your answer should be compact. -10.67. In the year 2002, what is the difference between the Amount of imports(as % of merchandise imports) in Manufactures and Amount of imports(as % of merchandise imports) in Fuel?
Offer a very short reply. 14.93. What is the ratio of the Amount of imports(as % of merchandise imports) of Ores and metals in 1981 to that in 1982?
Your response must be concise. 0.61. What is the ratio of the Amount of imports(as % of merchandise imports) of Manufactures in 1981 to that in 1982?
Offer a terse response. 0.87. What is the ratio of the Amount of imports(as % of merchandise imports) in Fuel in 1981 to that in 1982?
Provide a succinct answer. 0.97. What is the ratio of the Amount of imports(as % of merchandise imports) in Ores and metals in 1981 to that in 1985?
Make the answer very short. 0.33. What is the ratio of the Amount of imports(as % of merchandise imports) in Manufactures in 1981 to that in 1985?
Ensure brevity in your answer.  0.85. What is the ratio of the Amount of imports(as % of merchandise imports) of Fuel in 1981 to that in 1985?
Ensure brevity in your answer.  1.3. What is the ratio of the Amount of imports(as % of merchandise imports) of Ores and metals in 1981 to that in 1997?
Your answer should be compact. 1.44. What is the ratio of the Amount of imports(as % of merchandise imports) of Manufactures in 1981 to that in 1997?
Provide a short and direct response. 0.87. What is the ratio of the Amount of imports(as % of merchandise imports) in Fuel in 1981 to that in 1997?
Offer a very short reply. 1.49. What is the ratio of the Amount of imports(as % of merchandise imports) in Ores and metals in 1981 to that in 1998?
Provide a succinct answer. 0.87. What is the ratio of the Amount of imports(as % of merchandise imports) in Manufactures in 1981 to that in 1998?
Your response must be concise. 0.78. What is the ratio of the Amount of imports(as % of merchandise imports) of Fuel in 1981 to that in 1998?
Keep it short and to the point. 1.42. What is the ratio of the Amount of imports(as % of merchandise imports) in Ores and metals in 1981 to that in 1999?
Offer a very short reply. 0.47. What is the ratio of the Amount of imports(as % of merchandise imports) in Manufactures in 1981 to that in 1999?
Ensure brevity in your answer.  0.82. What is the ratio of the Amount of imports(as % of merchandise imports) in Fuel in 1981 to that in 1999?
Provide a short and direct response. 1.76. What is the ratio of the Amount of imports(as % of merchandise imports) in Ores and metals in 1981 to that in 2001?
Make the answer very short. 1.34. What is the ratio of the Amount of imports(as % of merchandise imports) in Manufactures in 1981 to that in 2001?
Ensure brevity in your answer.  1.41. What is the ratio of the Amount of imports(as % of merchandise imports) in Fuel in 1981 to that in 2001?
Keep it short and to the point. 10.61. What is the ratio of the Amount of imports(as % of merchandise imports) of Ores and metals in 1981 to that in 2002?
Provide a short and direct response. 0.88. What is the ratio of the Amount of imports(as % of merchandise imports) of Manufactures in 1981 to that in 2002?
Your answer should be compact. 1.69. What is the ratio of the Amount of imports(as % of merchandise imports) in Fuel in 1981 to that in 2002?
Offer a very short reply. 1.47. What is the ratio of the Amount of imports(as % of merchandise imports) in Ores and metals in 1982 to that in 1985?
Your response must be concise. 0.54. What is the ratio of the Amount of imports(as % of merchandise imports) in Manufactures in 1982 to that in 1985?
Provide a succinct answer. 0.97. What is the ratio of the Amount of imports(as % of merchandise imports) in Fuel in 1982 to that in 1985?
Provide a succinct answer. 1.34. What is the ratio of the Amount of imports(as % of merchandise imports) of Ores and metals in 1982 to that in 1997?
Offer a terse response. 2.37. What is the ratio of the Amount of imports(as % of merchandise imports) in Fuel in 1982 to that in 1997?
Provide a succinct answer. 1.54. What is the ratio of the Amount of imports(as % of merchandise imports) in Ores and metals in 1982 to that in 1998?
Provide a succinct answer. 1.43. What is the ratio of the Amount of imports(as % of merchandise imports) of Manufactures in 1982 to that in 1998?
Give a very brief answer. 0.89. What is the ratio of the Amount of imports(as % of merchandise imports) in Fuel in 1982 to that in 1998?
Provide a short and direct response. 1.47. What is the ratio of the Amount of imports(as % of merchandise imports) in Ores and metals in 1982 to that in 1999?
Keep it short and to the point. 0.77. What is the ratio of the Amount of imports(as % of merchandise imports) of Manufactures in 1982 to that in 1999?
Keep it short and to the point. 0.94. What is the ratio of the Amount of imports(as % of merchandise imports) of Fuel in 1982 to that in 1999?
Keep it short and to the point. 1.82. What is the ratio of the Amount of imports(as % of merchandise imports) in Ores and metals in 1982 to that in 2001?
Offer a very short reply. 2.2. What is the ratio of the Amount of imports(as % of merchandise imports) in Manufactures in 1982 to that in 2001?
Keep it short and to the point. 1.62. What is the ratio of the Amount of imports(as % of merchandise imports) of Fuel in 1982 to that in 2001?
Give a very brief answer. 10.96. What is the ratio of the Amount of imports(as % of merchandise imports) in Ores and metals in 1982 to that in 2002?
Give a very brief answer. 1.44. What is the ratio of the Amount of imports(as % of merchandise imports) in Manufactures in 1982 to that in 2002?
Provide a succinct answer. 1.94. What is the ratio of the Amount of imports(as % of merchandise imports) of Fuel in 1982 to that in 2002?
Provide a succinct answer. 1.52. What is the ratio of the Amount of imports(as % of merchandise imports) of Ores and metals in 1985 to that in 1997?
Your answer should be compact. 4.38. What is the ratio of the Amount of imports(as % of merchandise imports) of Manufactures in 1985 to that in 1997?
Ensure brevity in your answer.  1.02. What is the ratio of the Amount of imports(as % of merchandise imports) of Fuel in 1985 to that in 1997?
Keep it short and to the point. 1.15. What is the ratio of the Amount of imports(as % of merchandise imports) of Ores and metals in 1985 to that in 1998?
Your response must be concise. 2.63. What is the ratio of the Amount of imports(as % of merchandise imports) of Manufactures in 1985 to that in 1998?
Offer a very short reply. 0.92. What is the ratio of the Amount of imports(as % of merchandise imports) of Fuel in 1985 to that in 1998?
Make the answer very short. 1.09. What is the ratio of the Amount of imports(as % of merchandise imports) of Ores and metals in 1985 to that in 1999?
Provide a short and direct response. 1.43. What is the ratio of the Amount of imports(as % of merchandise imports) of Manufactures in 1985 to that in 1999?
Give a very brief answer. 0.97. What is the ratio of the Amount of imports(as % of merchandise imports) in Fuel in 1985 to that in 1999?
Give a very brief answer. 1.35. What is the ratio of the Amount of imports(as % of merchandise imports) of Ores and metals in 1985 to that in 2001?
Give a very brief answer. 4.07. What is the ratio of the Amount of imports(as % of merchandise imports) in Manufactures in 1985 to that in 2001?
Your answer should be very brief. 1.67. What is the ratio of the Amount of imports(as % of merchandise imports) in Fuel in 1985 to that in 2001?
Provide a succinct answer. 8.15. What is the ratio of the Amount of imports(as % of merchandise imports) in Ores and metals in 1985 to that in 2002?
Give a very brief answer. 2.65. What is the ratio of the Amount of imports(as % of merchandise imports) of Manufactures in 1985 to that in 2002?
Your answer should be very brief. 2. What is the ratio of the Amount of imports(as % of merchandise imports) of Fuel in 1985 to that in 2002?
Provide a short and direct response. 1.13. What is the ratio of the Amount of imports(as % of merchandise imports) of Ores and metals in 1997 to that in 1998?
Your answer should be compact. 0.6. What is the ratio of the Amount of imports(as % of merchandise imports) in Manufactures in 1997 to that in 1998?
Ensure brevity in your answer.  0.9. What is the ratio of the Amount of imports(as % of merchandise imports) of Fuel in 1997 to that in 1998?
Your answer should be compact. 0.95. What is the ratio of the Amount of imports(as % of merchandise imports) of Ores and metals in 1997 to that in 1999?
Your response must be concise. 0.33. What is the ratio of the Amount of imports(as % of merchandise imports) in Manufactures in 1997 to that in 1999?
Ensure brevity in your answer.  0.94. What is the ratio of the Amount of imports(as % of merchandise imports) in Fuel in 1997 to that in 1999?
Make the answer very short. 1.18. What is the ratio of the Amount of imports(as % of merchandise imports) of Ores and metals in 1997 to that in 2001?
Your response must be concise. 0.93. What is the ratio of the Amount of imports(as % of merchandise imports) in Manufactures in 1997 to that in 2001?
Ensure brevity in your answer.  1.63. What is the ratio of the Amount of imports(as % of merchandise imports) of Fuel in 1997 to that in 2001?
Provide a succinct answer. 7.11. What is the ratio of the Amount of imports(as % of merchandise imports) of Ores and metals in 1997 to that in 2002?
Your answer should be very brief. 0.61. What is the ratio of the Amount of imports(as % of merchandise imports) of Manufactures in 1997 to that in 2002?
Provide a short and direct response. 1.96. What is the ratio of the Amount of imports(as % of merchandise imports) in Fuel in 1997 to that in 2002?
Your answer should be very brief. 0.98. What is the ratio of the Amount of imports(as % of merchandise imports) of Ores and metals in 1998 to that in 1999?
Your answer should be compact. 0.54. What is the ratio of the Amount of imports(as % of merchandise imports) in Manufactures in 1998 to that in 1999?
Keep it short and to the point. 1.05. What is the ratio of the Amount of imports(as % of merchandise imports) of Fuel in 1998 to that in 1999?
Provide a succinct answer. 1.24. What is the ratio of the Amount of imports(as % of merchandise imports) in Ores and metals in 1998 to that in 2001?
Ensure brevity in your answer.  1.54. What is the ratio of the Amount of imports(as % of merchandise imports) of Manufactures in 1998 to that in 2001?
Keep it short and to the point. 1.82. What is the ratio of the Amount of imports(as % of merchandise imports) of Fuel in 1998 to that in 2001?
Make the answer very short. 7.46. What is the ratio of the Amount of imports(as % of merchandise imports) in Ores and metals in 1998 to that in 2002?
Your answer should be compact. 1.01. What is the ratio of the Amount of imports(as % of merchandise imports) of Manufactures in 1998 to that in 2002?
Offer a terse response. 2.18. What is the ratio of the Amount of imports(as % of merchandise imports) in Fuel in 1998 to that in 2002?
Give a very brief answer. 1.03. What is the ratio of the Amount of imports(as % of merchandise imports) in Ores and metals in 1999 to that in 2001?
Provide a succinct answer. 2.85. What is the ratio of the Amount of imports(as % of merchandise imports) of Manufactures in 1999 to that in 2001?
Make the answer very short. 1.73. What is the ratio of the Amount of imports(as % of merchandise imports) in Fuel in 1999 to that in 2001?
Provide a short and direct response. 6.03. What is the ratio of the Amount of imports(as % of merchandise imports) of Ores and metals in 1999 to that in 2002?
Provide a succinct answer. 1.86. What is the ratio of the Amount of imports(as % of merchandise imports) of Manufactures in 1999 to that in 2002?
Provide a succinct answer. 2.07. What is the ratio of the Amount of imports(as % of merchandise imports) in Fuel in 1999 to that in 2002?
Keep it short and to the point. 0.83. What is the ratio of the Amount of imports(as % of merchandise imports) in Ores and metals in 2001 to that in 2002?
Offer a very short reply. 0.65. What is the ratio of the Amount of imports(as % of merchandise imports) in Manufactures in 2001 to that in 2002?
Your response must be concise. 1.2. What is the ratio of the Amount of imports(as % of merchandise imports) of Fuel in 2001 to that in 2002?
Offer a very short reply. 0.14. What is the difference between the highest and the second highest Amount of imports(as % of merchandise imports) in Ores and metals?
Ensure brevity in your answer.  0.31. What is the difference between the highest and the second highest Amount of imports(as % of merchandise imports) of Manufactures?
Your response must be concise. 2.76. What is the difference between the highest and the second highest Amount of imports(as % of merchandise imports) in Fuel?
Offer a terse response. 0.53. What is the difference between the highest and the lowest Amount of imports(as % of merchandise imports) of Ores and metals?
Provide a succinct answer. 0.8. What is the difference between the highest and the lowest Amount of imports(as % of merchandise imports) in Manufactures?
Offer a very short reply. 30.61. What is the difference between the highest and the lowest Amount of imports(as % of merchandise imports) of Fuel?
Give a very brief answer. 15.24. 